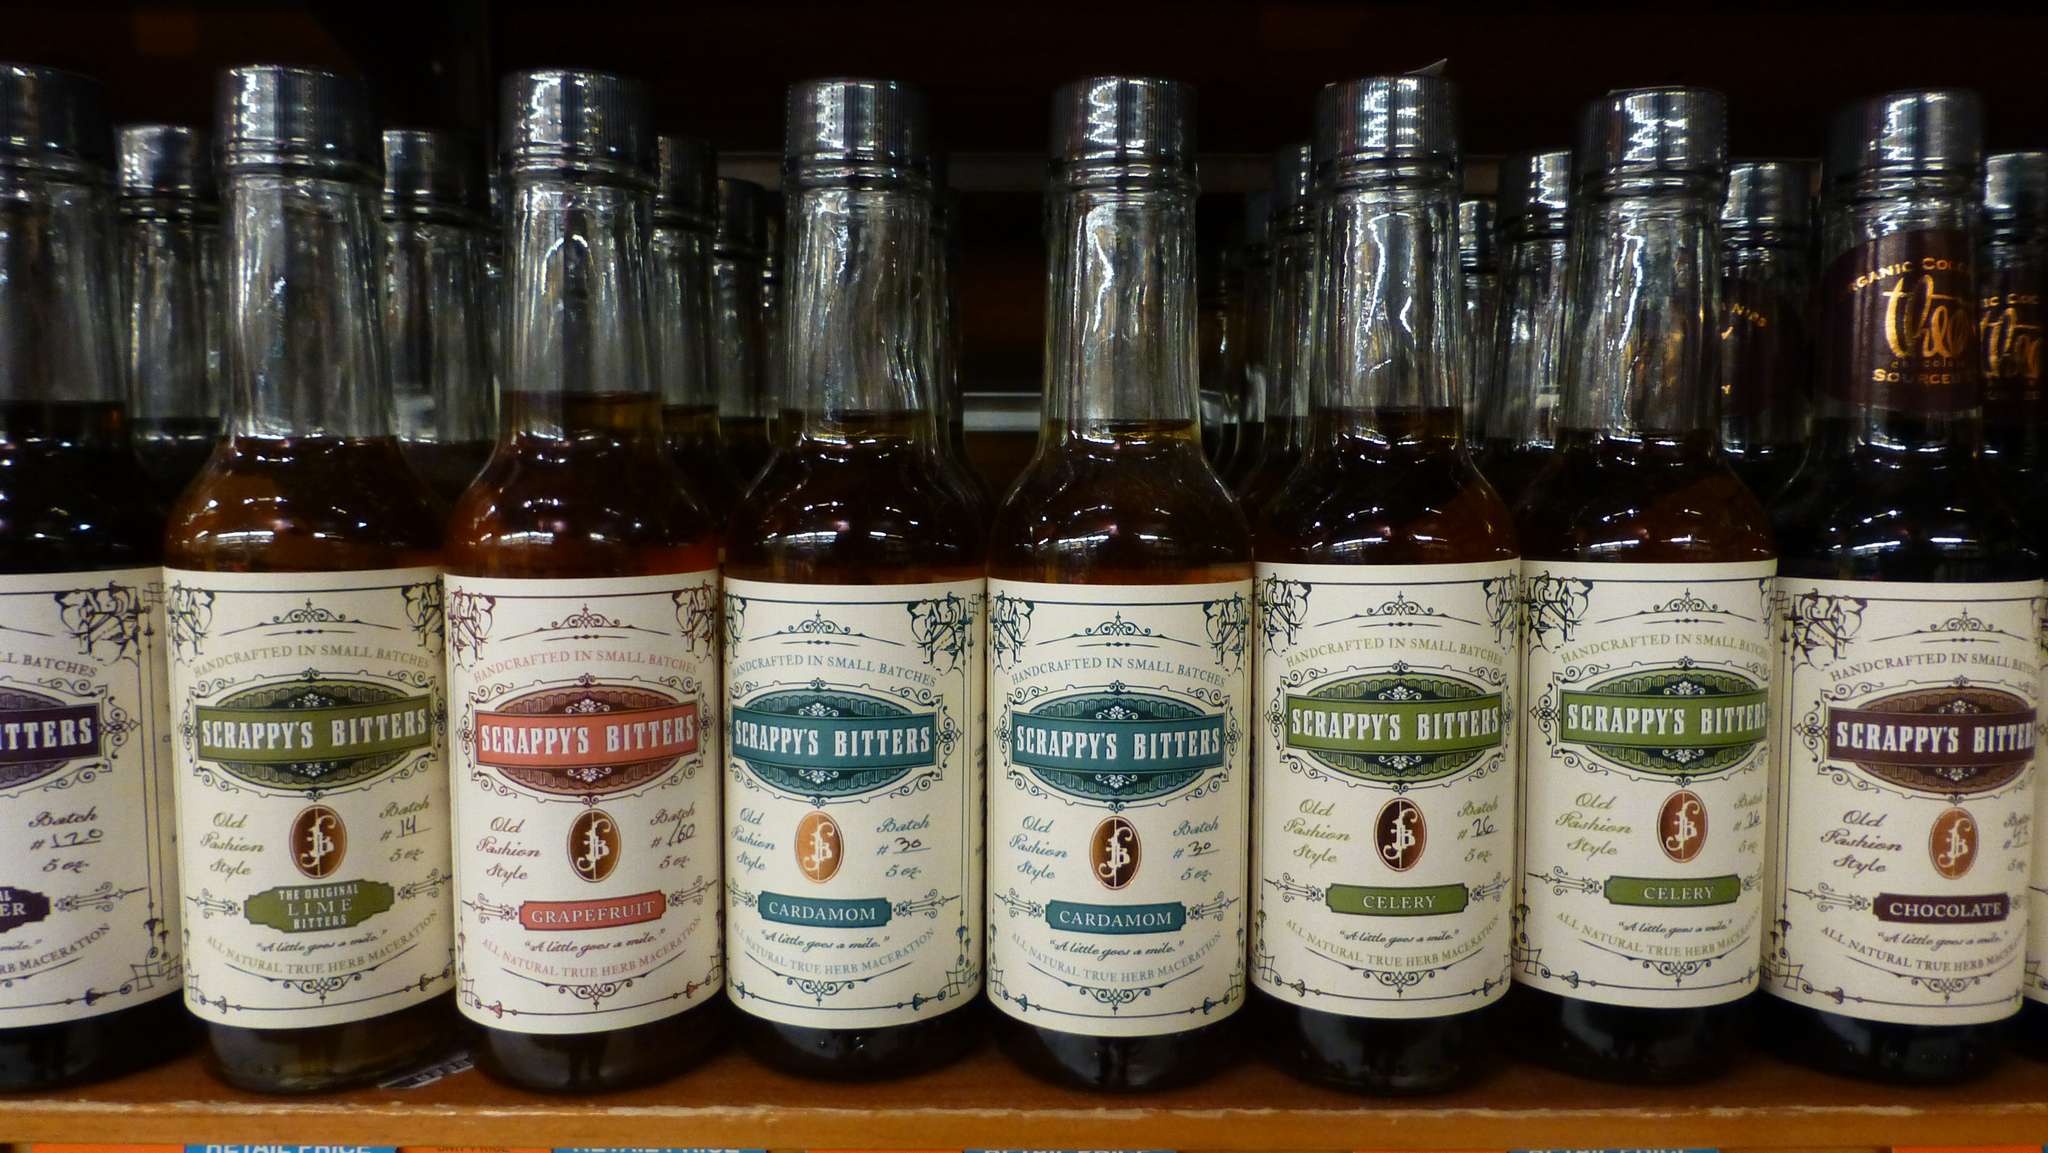Could you give a brief overview of what you see in this image? In this image I can see number of bottles. 